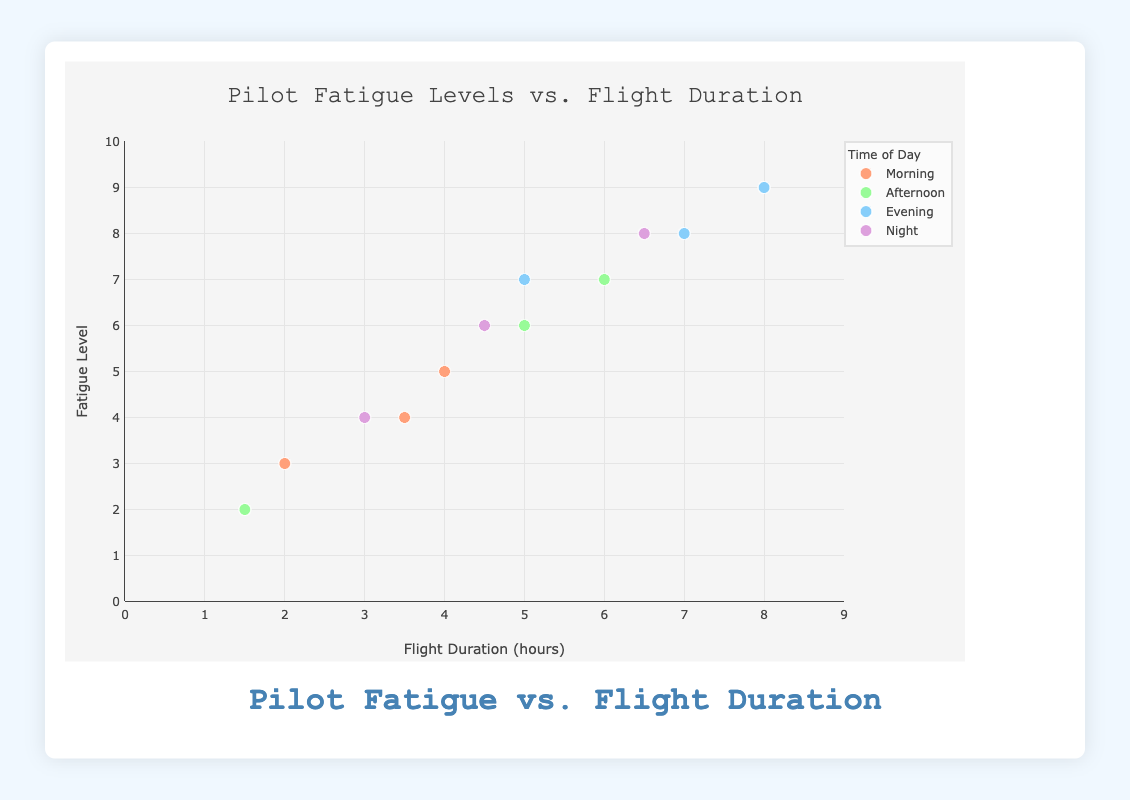What's the title of the chart? The title of the chart is displayed at the top of the plot area. It states "Pilot Fatigue Levels vs. Flight Duration".
Answer: Pilot Fatigue Levels vs. Flight Duration Which time of day has the data points with the highest fatigue levels? By observing the vertical position of the data points on the y-axis, which represents fatigue levels, the highest values (8 and 9) are seen for the Evening sessions.
Answer: Evening How many data points are there for the Morning time of day? The legend shows a color for each time of day, and the scatter plot has a different number of data points corresponding to each color. Specifically, for the Morning (one color group), there are three data points.
Answer: 3 What is the average flight duration for Afternoon flights? The flight durations for Afternoon are 6, 1.5, and 5 hours. Summing these up gives 12.5. Dividing by the three data points, the average flight duration is 12.5 / 3.
Answer: 4.17 hours Which time of day has the widest range of fatigue levels? To find the range, subtract the minimum fatigue level from the maximum for each time of day. For Morning: 5 - 3 = 2. For Afternoon: 7 - 2 = 5. For Evening: 9 - 7 = 2. For Night: 8 - 4 = 4. The widest range is 5 for Afternoon.
Answer: Afternoon What is the fatigue level of the pilot who flew for the shortest duration during the Night? Looking at the scatter plot for Night (one color group), the shortest flight duration is 3 hours, with the corresponding fatigue level marked at 4.
Answer: 4 Compare the average fatigue levels of Afternoon and Evening flights. Which one is higher? For Afternoon: fatigue levels are 7, 2, and 6. Average = (7 + 2 + 6) / 3 = 5. For Evening: fatigue levels are 9, 8, and 7. Average = (9 + 8 + 7) / 3 = 8.0. The average fatigue for Evening is higher.
Answer: Evening Which pilot had a flight duration of exactly 4 hours? The data point with a flight duration of 4 hours is in the Morning time of day. The corresponding pilot ID is shown as `Pilot ID: P002` in the hover information.
Answer: Pilot P002 What’s the range of flight durations for the Night time of day? The flight durations at Night are 3, 4.5, and 6.5 hours. The range is calculated as the maximum minus the minimum, which is 6.5 - 3.
Answer: 3.5 hours 